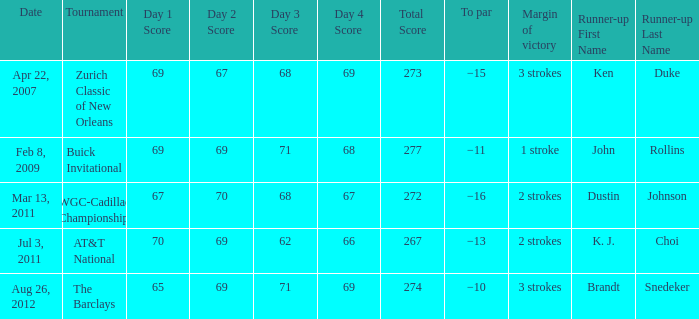What was the best performance in the championship where ken duke secured the second position? −15. 